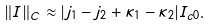<formula> <loc_0><loc_0><loc_500><loc_500>\| I \| _ { C } \approx | j _ { 1 } - j _ { 2 } + \kappa _ { 1 } - \kappa _ { 2 } | I _ { c 0 } .</formula> 